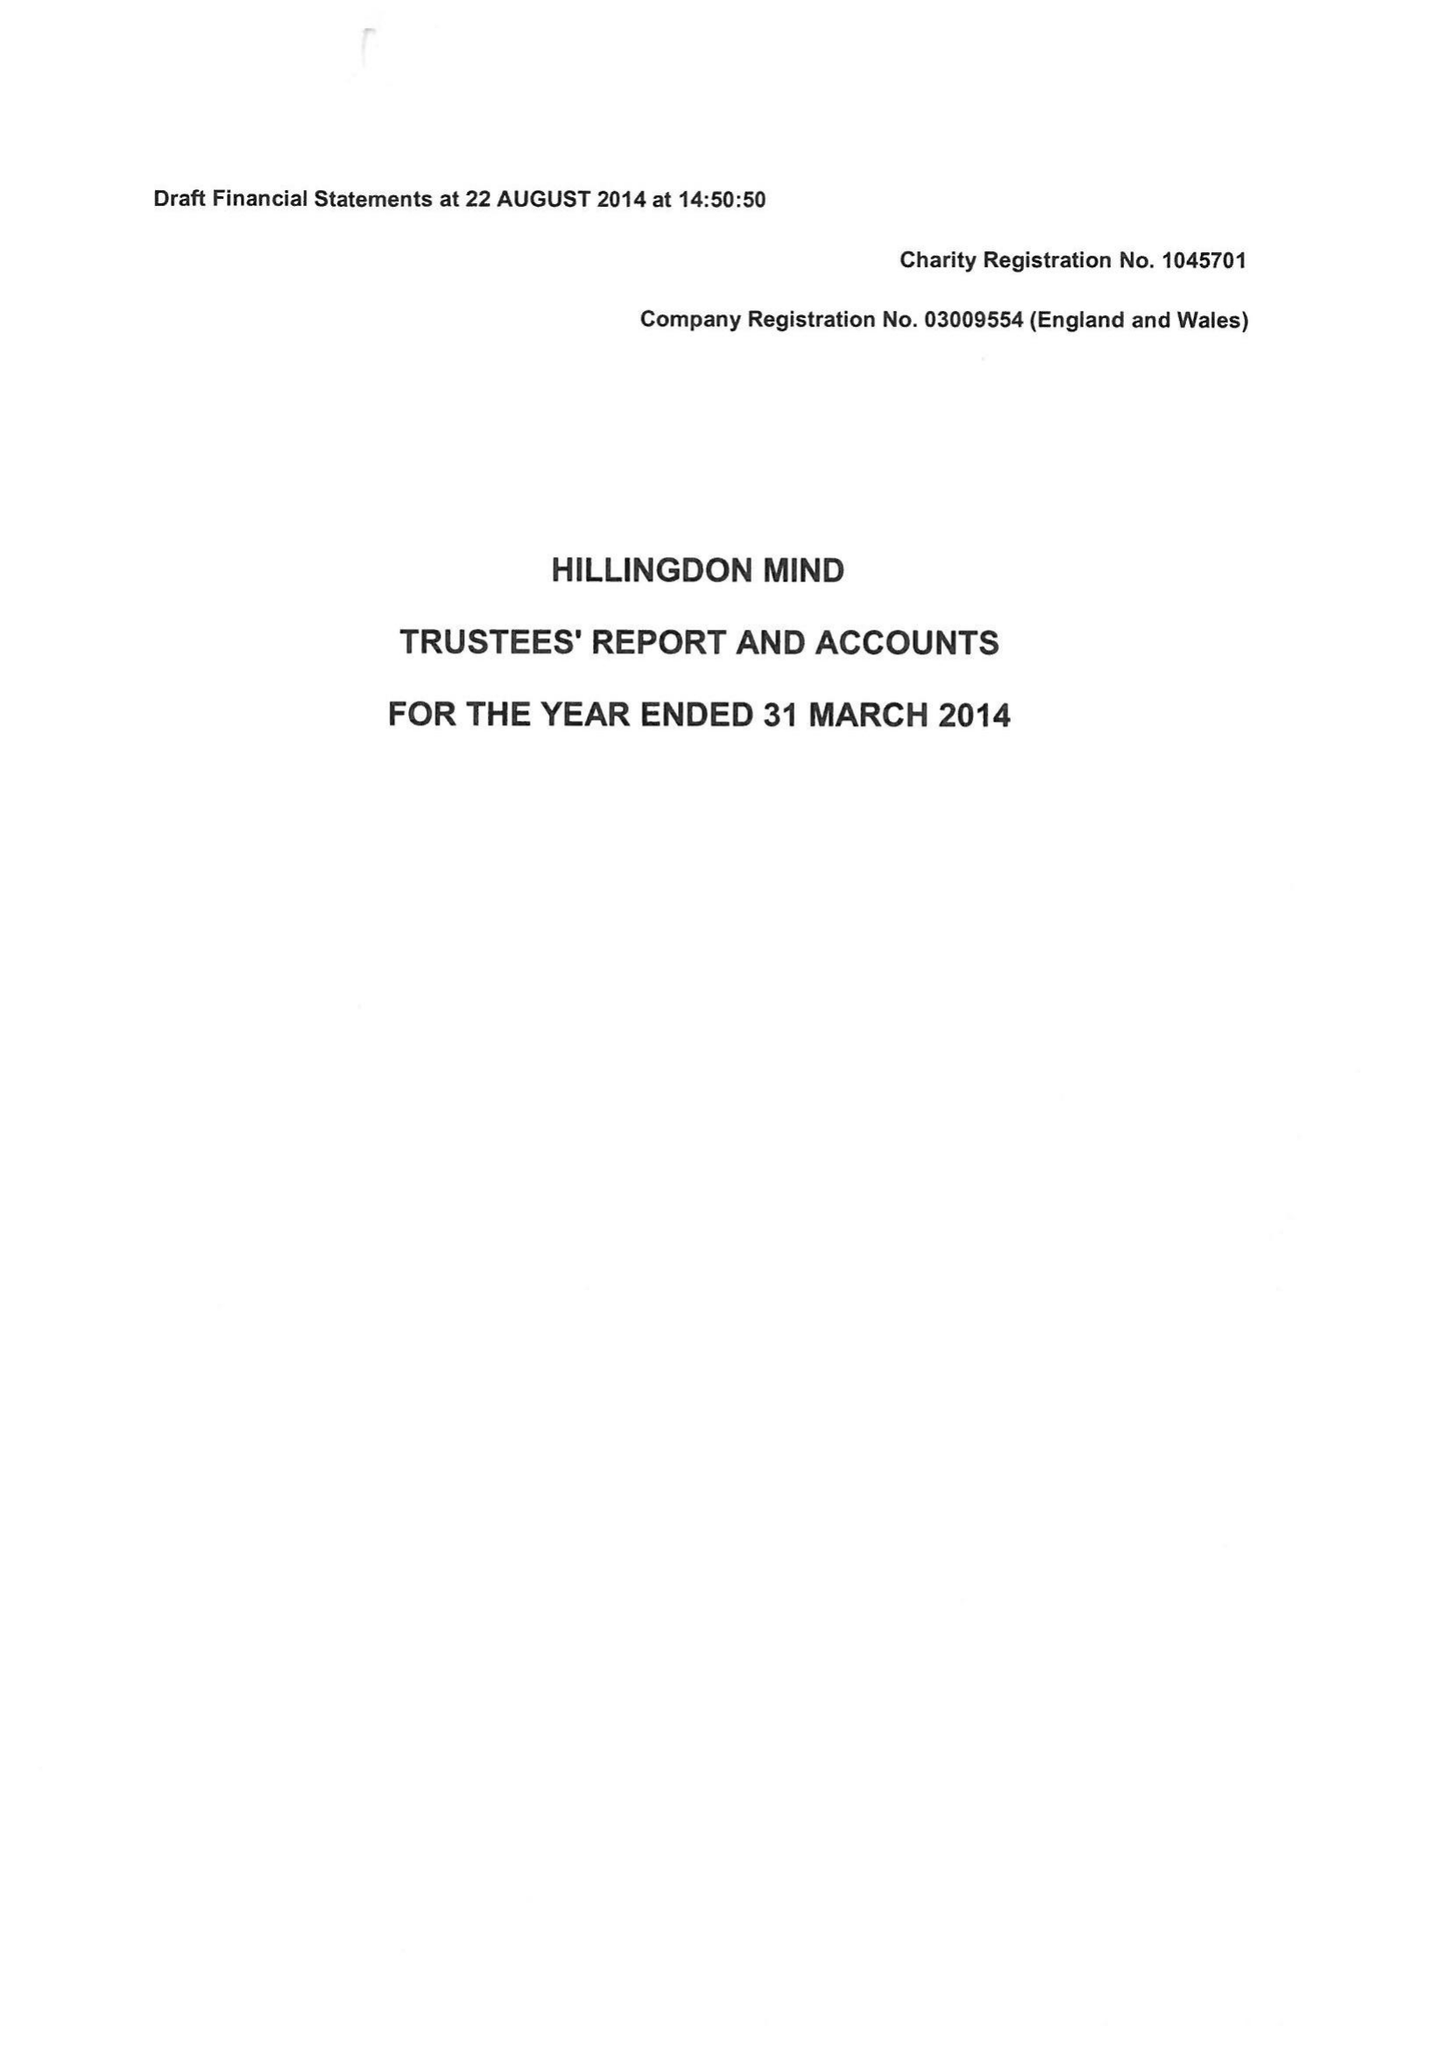What is the value for the charity_name?
Answer the question using a single word or phrase. Hillingdon Mind 